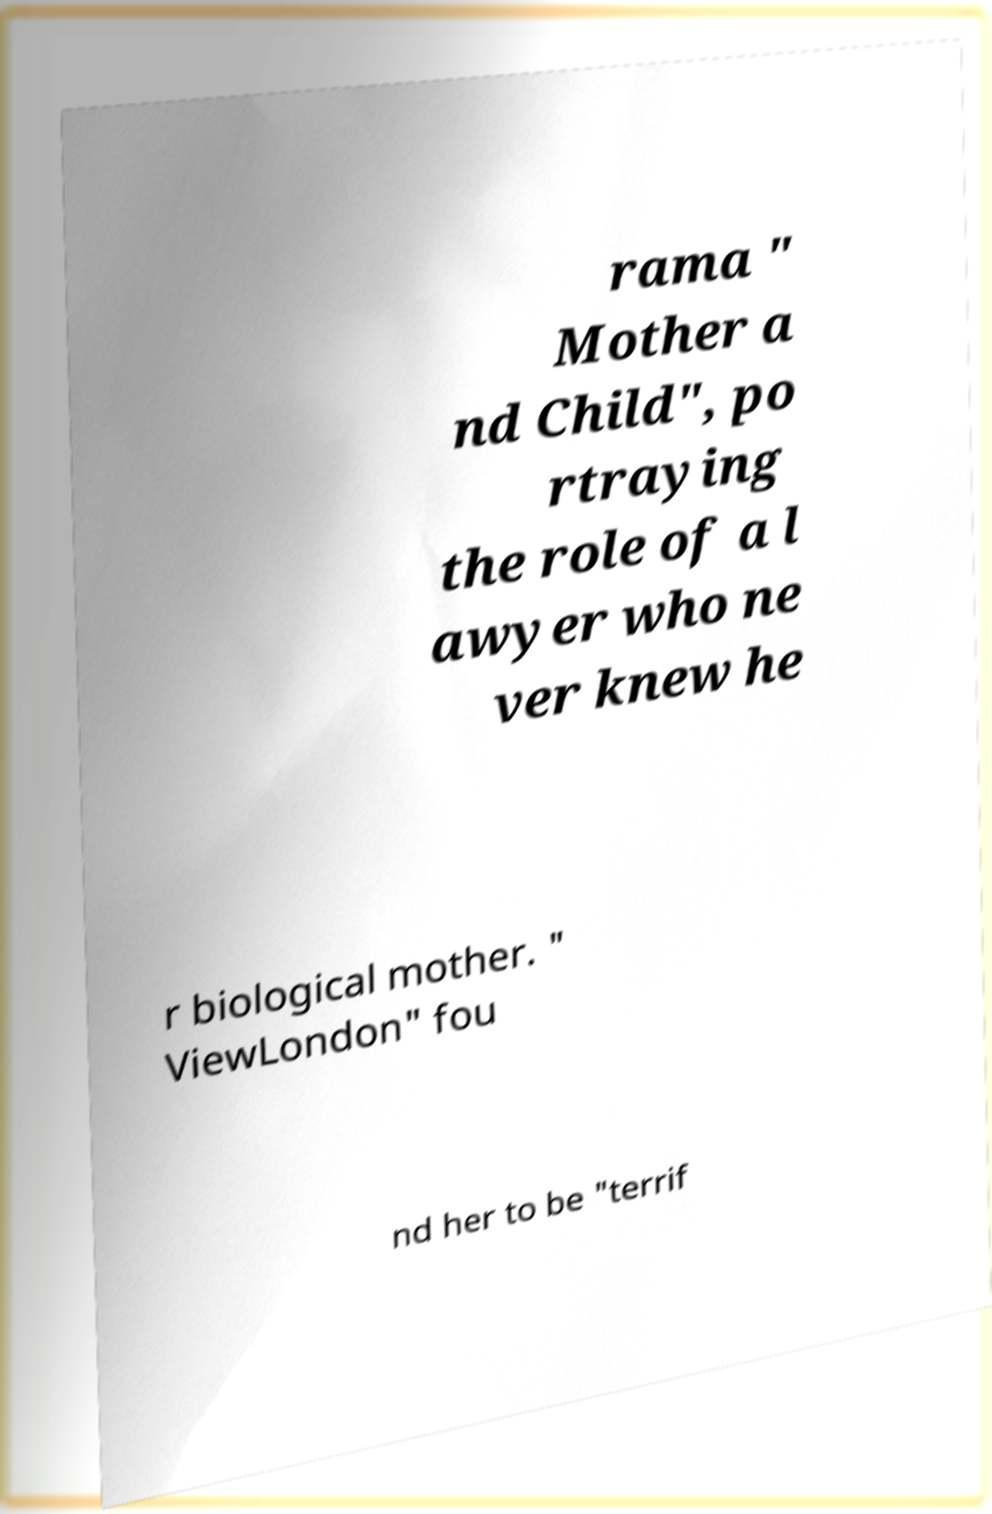Could you extract and type out the text from this image? rama " Mother a nd Child", po rtraying the role of a l awyer who ne ver knew he r biological mother. " ViewLondon" fou nd her to be "terrif 